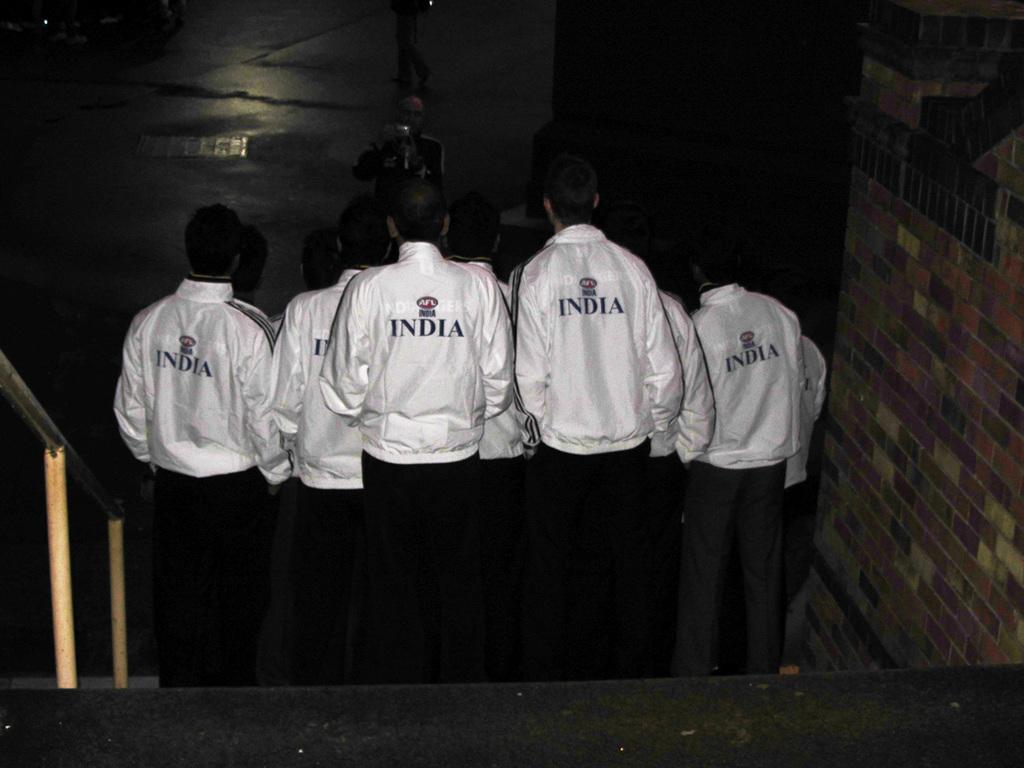What country are these people from?
Provide a succinct answer. India. What color are their matching jackets?
Provide a succinct answer. White. 